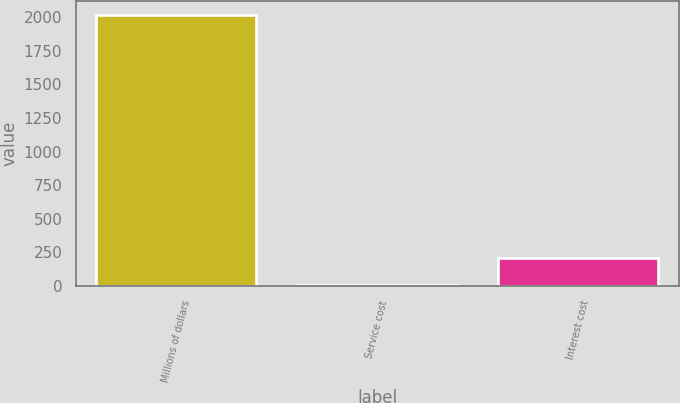<chart> <loc_0><loc_0><loc_500><loc_500><bar_chart><fcel>Millions of dollars<fcel>Service cost<fcel>Interest cost<nl><fcel>2018<fcel>7<fcel>208.1<nl></chart> 